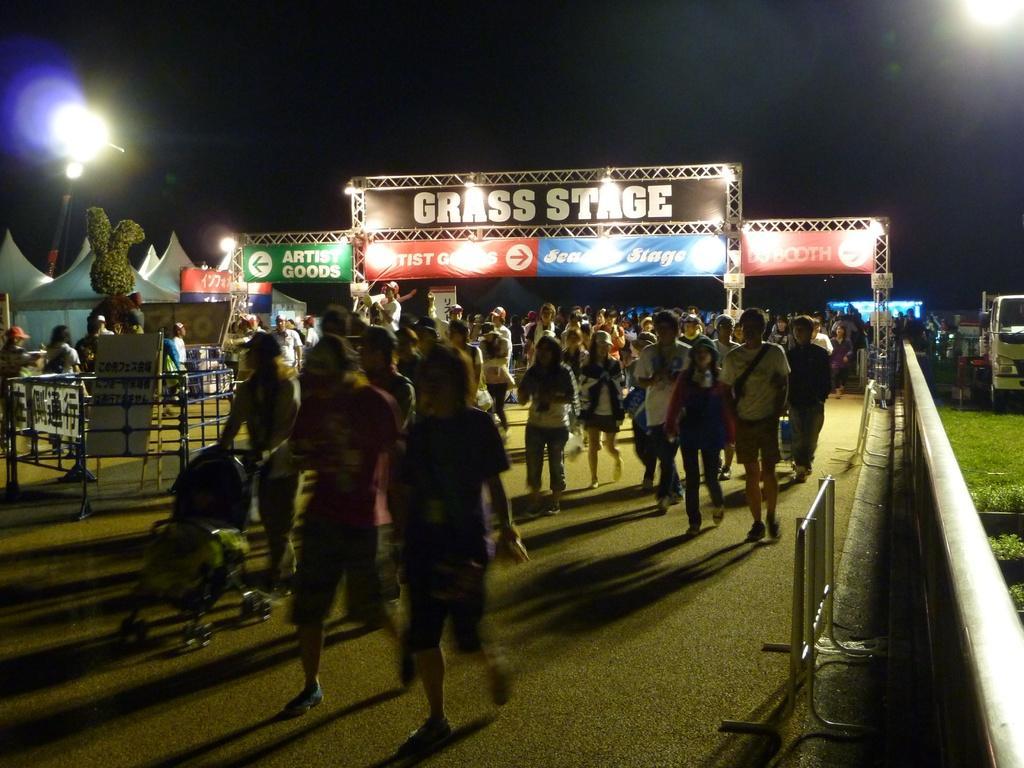In one or two sentences, can you explain what this image depicts? In this image we can see many paintings. Also there is a stroller. On the right side there is vehicle. On the ground there is grass. Also there are barricades. In the back there are banners. Also there are tents. In the background it is dark and we can see lights. 